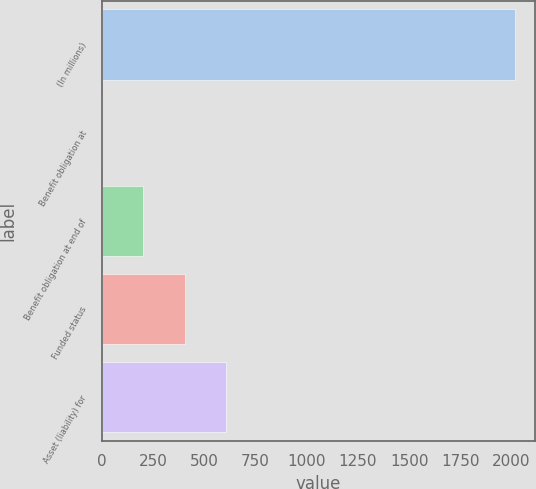<chart> <loc_0><loc_0><loc_500><loc_500><bar_chart><fcel>(In millions)<fcel>Benefit obligation at<fcel>Benefit obligation at end of<fcel>Funded status<fcel>Asset (liability) for<nl><fcel>2016<fcel>1<fcel>202.5<fcel>404<fcel>605.5<nl></chart> 